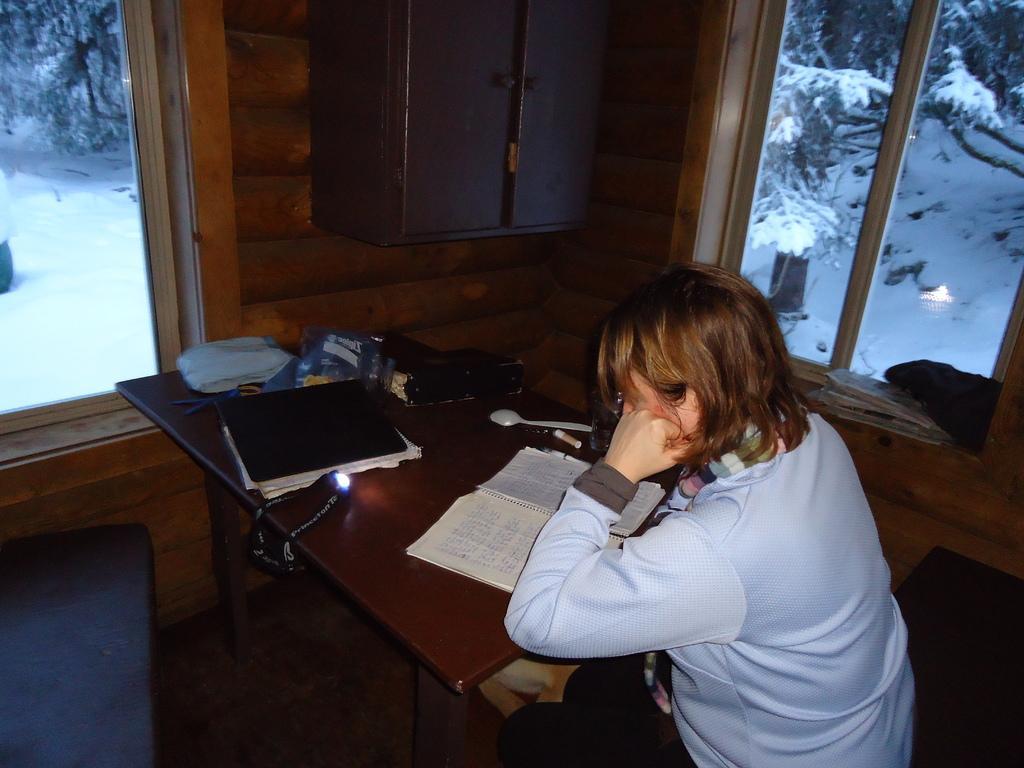In one or two sentences, can you explain what this image depicts? This image is clicked in a room where there are trees in the top. There is a table and chair in the middle. on the table their books, paper, spoon, cover. Woman is sitting on chair near the table. There are Windows on right and left side. 